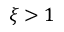<formula> <loc_0><loc_0><loc_500><loc_500>\xi > 1</formula> 